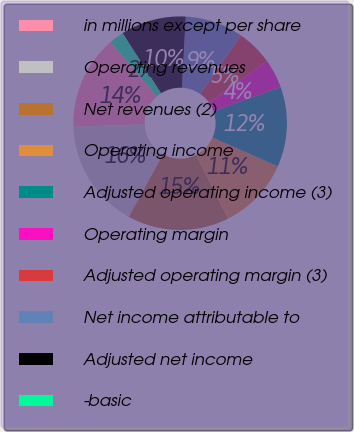<chart> <loc_0><loc_0><loc_500><loc_500><pie_chart><fcel>in millions except per share<fcel>Operating revenues<fcel>Net revenues (2)<fcel>Operating income<fcel>Adjusted operating income (3)<fcel>Operating margin<fcel>Adjusted operating margin (3)<fcel>Net income attributable to<fcel>Adjusted net income<fcel>-basic<nl><fcel>14.29%<fcel>16.48%<fcel>15.38%<fcel>10.99%<fcel>12.09%<fcel>4.4%<fcel>5.49%<fcel>8.79%<fcel>9.89%<fcel>2.2%<nl></chart> 